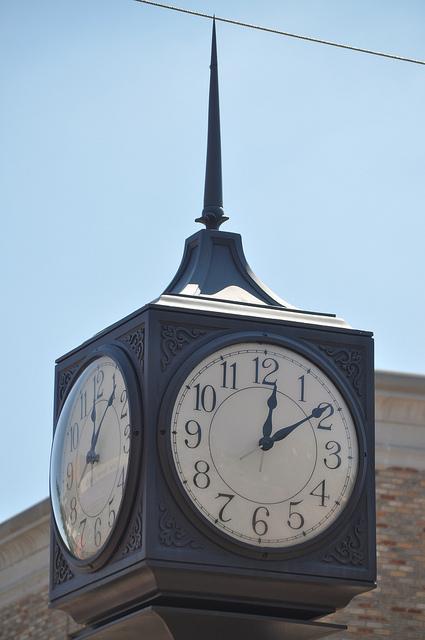What time is it here?
Answer briefly. 12:10. Which metal is the clock box made of?
Keep it brief. Bronze. How many sides to this clock?
Keep it brief. 4. 